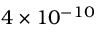Convert formula to latex. <formula><loc_0><loc_0><loc_500><loc_500>4 \times 1 0 ^ { - 1 0 }</formula> 